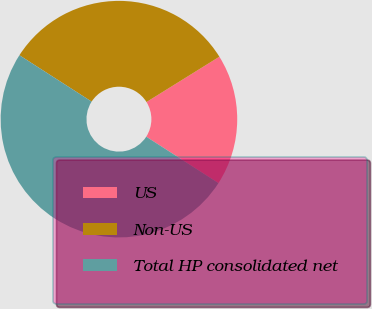Convert chart to OTSL. <chart><loc_0><loc_0><loc_500><loc_500><pie_chart><fcel>US<fcel>Non-US<fcel>Total HP consolidated net<nl><fcel>17.94%<fcel>32.06%<fcel>50.0%<nl></chart> 